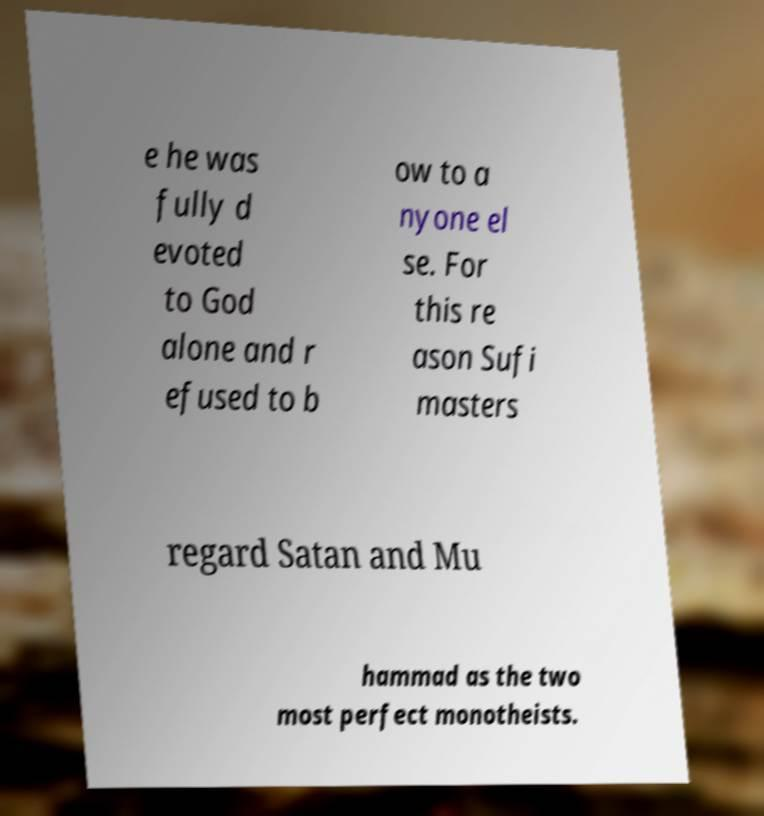There's text embedded in this image that I need extracted. Can you transcribe it verbatim? e he was fully d evoted to God alone and r efused to b ow to a nyone el se. For this re ason Sufi masters regard Satan and Mu hammad as the two most perfect monotheists. 